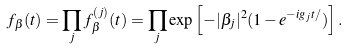<formula> <loc_0><loc_0><loc_500><loc_500>f _ { \beta } ( t ) = \prod _ { j } f _ { \beta } ^ { ( j ) } ( t ) = \prod _ { j } \exp \left [ - | \beta _ { j } | ^ { 2 } ( 1 - e ^ { - i g _ { j } t / } ) \right ] .</formula> 